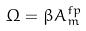Convert formula to latex. <formula><loc_0><loc_0><loc_500><loc_500>\Omega = \beta A _ { m } ^ { f p }</formula> 